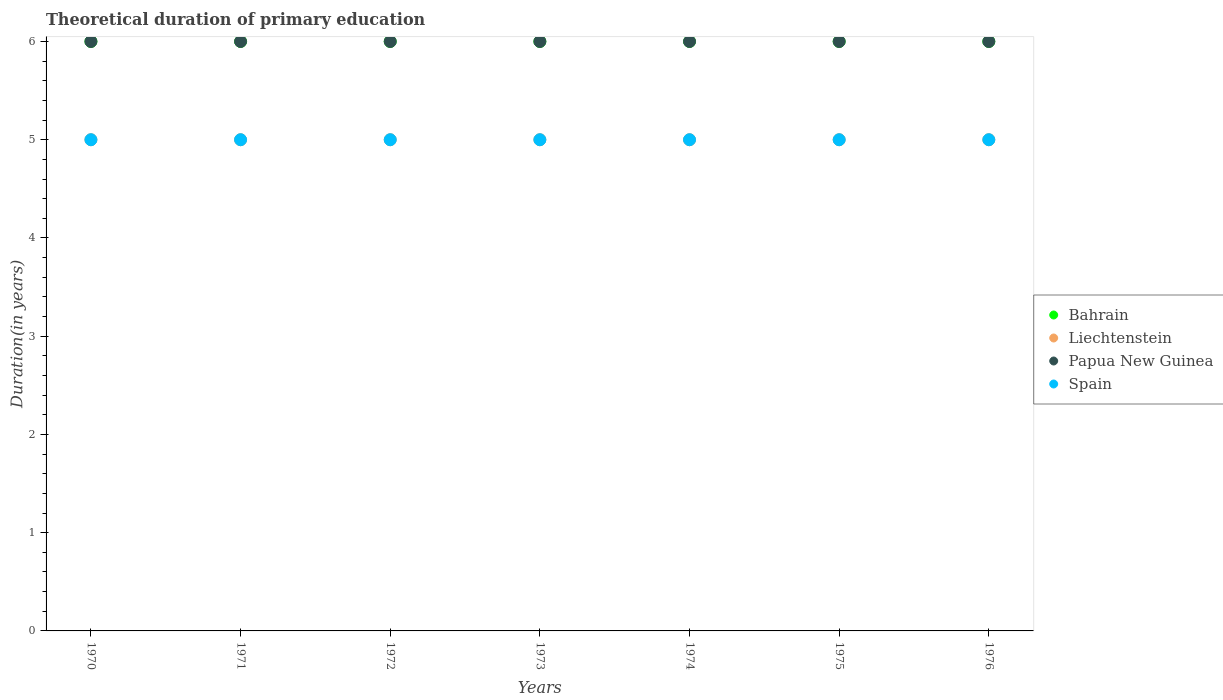How many different coloured dotlines are there?
Keep it short and to the point. 4. What is the total theoretical duration of primary education in Liechtenstein in 1973?
Your answer should be very brief. 5. Across all years, what is the minimum total theoretical duration of primary education in Papua New Guinea?
Provide a short and direct response. 6. In which year was the total theoretical duration of primary education in Bahrain maximum?
Make the answer very short. 1970. What is the total total theoretical duration of primary education in Spain in the graph?
Your answer should be very brief. 35. What is the difference between the total theoretical duration of primary education in Bahrain in 1973 and the total theoretical duration of primary education in Liechtenstein in 1970?
Your answer should be compact. 1. In the year 1971, what is the difference between the total theoretical duration of primary education in Spain and total theoretical duration of primary education in Papua New Guinea?
Offer a very short reply. -1. What is the difference between the highest and the second highest total theoretical duration of primary education in Papua New Guinea?
Give a very brief answer. 0. What is the difference between the highest and the lowest total theoretical duration of primary education in Papua New Guinea?
Your response must be concise. 0. In how many years, is the total theoretical duration of primary education in Papua New Guinea greater than the average total theoretical duration of primary education in Papua New Guinea taken over all years?
Provide a short and direct response. 0. Is the sum of the total theoretical duration of primary education in Spain in 1971 and 1973 greater than the maximum total theoretical duration of primary education in Liechtenstein across all years?
Your answer should be compact. Yes. Is the total theoretical duration of primary education in Bahrain strictly greater than the total theoretical duration of primary education in Papua New Guinea over the years?
Provide a short and direct response. No. What is the difference between two consecutive major ticks on the Y-axis?
Give a very brief answer. 1. Are the values on the major ticks of Y-axis written in scientific E-notation?
Your response must be concise. No. Does the graph contain any zero values?
Your answer should be very brief. No. Where does the legend appear in the graph?
Keep it short and to the point. Center right. What is the title of the graph?
Keep it short and to the point. Theoretical duration of primary education. Does "Fiji" appear as one of the legend labels in the graph?
Offer a very short reply. No. What is the label or title of the Y-axis?
Offer a terse response. Duration(in years). What is the Duration(in years) in Bahrain in 1970?
Provide a succinct answer. 6. What is the Duration(in years) in Papua New Guinea in 1970?
Your response must be concise. 6. What is the Duration(in years) of Bahrain in 1971?
Give a very brief answer. 6. What is the Duration(in years) in Spain in 1971?
Offer a terse response. 5. What is the Duration(in years) in Bahrain in 1973?
Offer a terse response. 6. What is the Duration(in years) in Bahrain in 1974?
Offer a terse response. 6. What is the Duration(in years) of Spain in 1974?
Keep it short and to the point. 5. What is the Duration(in years) of Bahrain in 1975?
Offer a terse response. 6. What is the Duration(in years) in Papua New Guinea in 1975?
Your answer should be compact. 6. What is the Duration(in years) in Spain in 1975?
Give a very brief answer. 5. What is the Duration(in years) in Bahrain in 1976?
Offer a terse response. 6. What is the Duration(in years) of Papua New Guinea in 1976?
Your response must be concise. 6. Across all years, what is the maximum Duration(in years) of Papua New Guinea?
Your answer should be compact. 6. Across all years, what is the minimum Duration(in years) of Papua New Guinea?
Provide a short and direct response. 6. Across all years, what is the minimum Duration(in years) of Spain?
Give a very brief answer. 5. What is the total Duration(in years) of Bahrain in the graph?
Your response must be concise. 42. What is the total Duration(in years) of Liechtenstein in the graph?
Your answer should be compact. 35. What is the total Duration(in years) of Spain in the graph?
Your answer should be very brief. 35. What is the difference between the Duration(in years) of Spain in 1970 and that in 1971?
Keep it short and to the point. 0. What is the difference between the Duration(in years) of Bahrain in 1970 and that in 1972?
Ensure brevity in your answer.  0. What is the difference between the Duration(in years) of Liechtenstein in 1970 and that in 1972?
Your answer should be compact. 0. What is the difference between the Duration(in years) in Papua New Guinea in 1970 and that in 1973?
Your answer should be compact. 0. What is the difference between the Duration(in years) in Bahrain in 1970 and that in 1974?
Your response must be concise. 0. What is the difference between the Duration(in years) in Liechtenstein in 1970 and that in 1974?
Your answer should be very brief. 0. What is the difference between the Duration(in years) in Papua New Guinea in 1970 and that in 1974?
Ensure brevity in your answer.  0. What is the difference between the Duration(in years) of Bahrain in 1970 and that in 1975?
Your answer should be very brief. 0. What is the difference between the Duration(in years) of Papua New Guinea in 1970 and that in 1975?
Give a very brief answer. 0. What is the difference between the Duration(in years) in Spain in 1970 and that in 1975?
Ensure brevity in your answer.  0. What is the difference between the Duration(in years) of Spain in 1970 and that in 1976?
Keep it short and to the point. 0. What is the difference between the Duration(in years) of Spain in 1971 and that in 1972?
Offer a terse response. 0. What is the difference between the Duration(in years) of Bahrain in 1971 and that in 1973?
Provide a short and direct response. 0. What is the difference between the Duration(in years) in Spain in 1971 and that in 1973?
Provide a succinct answer. 0. What is the difference between the Duration(in years) in Papua New Guinea in 1971 and that in 1974?
Give a very brief answer. 0. What is the difference between the Duration(in years) of Bahrain in 1971 and that in 1975?
Make the answer very short. 0. What is the difference between the Duration(in years) in Liechtenstein in 1971 and that in 1975?
Your answer should be compact. 0. What is the difference between the Duration(in years) of Papua New Guinea in 1971 and that in 1975?
Give a very brief answer. 0. What is the difference between the Duration(in years) in Spain in 1971 and that in 1975?
Your response must be concise. 0. What is the difference between the Duration(in years) of Bahrain in 1971 and that in 1976?
Offer a terse response. 0. What is the difference between the Duration(in years) in Liechtenstein in 1971 and that in 1976?
Give a very brief answer. 0. What is the difference between the Duration(in years) of Bahrain in 1972 and that in 1973?
Offer a very short reply. 0. What is the difference between the Duration(in years) of Bahrain in 1972 and that in 1974?
Provide a succinct answer. 0. What is the difference between the Duration(in years) of Bahrain in 1972 and that in 1976?
Your response must be concise. 0. What is the difference between the Duration(in years) in Liechtenstein in 1972 and that in 1976?
Your answer should be very brief. 0. What is the difference between the Duration(in years) in Papua New Guinea in 1972 and that in 1976?
Offer a terse response. 0. What is the difference between the Duration(in years) in Spain in 1972 and that in 1976?
Give a very brief answer. 0. What is the difference between the Duration(in years) of Spain in 1973 and that in 1974?
Provide a succinct answer. 0. What is the difference between the Duration(in years) in Spain in 1973 and that in 1975?
Make the answer very short. 0. What is the difference between the Duration(in years) of Bahrain in 1974 and that in 1975?
Ensure brevity in your answer.  0. What is the difference between the Duration(in years) of Liechtenstein in 1974 and that in 1975?
Your response must be concise. 0. What is the difference between the Duration(in years) of Spain in 1974 and that in 1975?
Offer a very short reply. 0. What is the difference between the Duration(in years) of Bahrain in 1974 and that in 1976?
Offer a terse response. 0. What is the difference between the Duration(in years) of Bahrain in 1975 and that in 1976?
Give a very brief answer. 0. What is the difference between the Duration(in years) in Papua New Guinea in 1975 and that in 1976?
Offer a terse response. 0. What is the difference between the Duration(in years) of Bahrain in 1970 and the Duration(in years) of Liechtenstein in 1971?
Provide a succinct answer. 1. What is the difference between the Duration(in years) in Bahrain in 1970 and the Duration(in years) in Papua New Guinea in 1971?
Your response must be concise. 0. What is the difference between the Duration(in years) in Bahrain in 1970 and the Duration(in years) in Spain in 1971?
Make the answer very short. 1. What is the difference between the Duration(in years) in Liechtenstein in 1970 and the Duration(in years) in Papua New Guinea in 1971?
Your response must be concise. -1. What is the difference between the Duration(in years) of Bahrain in 1970 and the Duration(in years) of Papua New Guinea in 1972?
Keep it short and to the point. 0. What is the difference between the Duration(in years) of Liechtenstein in 1970 and the Duration(in years) of Spain in 1972?
Make the answer very short. 0. What is the difference between the Duration(in years) in Papua New Guinea in 1970 and the Duration(in years) in Spain in 1972?
Ensure brevity in your answer.  1. What is the difference between the Duration(in years) of Bahrain in 1970 and the Duration(in years) of Papua New Guinea in 1973?
Offer a very short reply. 0. What is the difference between the Duration(in years) in Bahrain in 1970 and the Duration(in years) in Spain in 1973?
Your answer should be very brief. 1. What is the difference between the Duration(in years) in Liechtenstein in 1970 and the Duration(in years) in Papua New Guinea in 1973?
Offer a very short reply. -1. What is the difference between the Duration(in years) of Liechtenstein in 1970 and the Duration(in years) of Spain in 1973?
Your response must be concise. 0. What is the difference between the Duration(in years) of Bahrain in 1970 and the Duration(in years) of Papua New Guinea in 1974?
Ensure brevity in your answer.  0. What is the difference between the Duration(in years) of Liechtenstein in 1970 and the Duration(in years) of Papua New Guinea in 1974?
Offer a very short reply. -1. What is the difference between the Duration(in years) in Liechtenstein in 1970 and the Duration(in years) in Spain in 1974?
Your response must be concise. 0. What is the difference between the Duration(in years) in Papua New Guinea in 1970 and the Duration(in years) in Spain in 1974?
Provide a succinct answer. 1. What is the difference between the Duration(in years) of Bahrain in 1970 and the Duration(in years) of Liechtenstein in 1975?
Keep it short and to the point. 1. What is the difference between the Duration(in years) in Bahrain in 1970 and the Duration(in years) in Papua New Guinea in 1975?
Offer a very short reply. 0. What is the difference between the Duration(in years) of Bahrain in 1970 and the Duration(in years) of Papua New Guinea in 1976?
Provide a succinct answer. 0. What is the difference between the Duration(in years) of Liechtenstein in 1970 and the Duration(in years) of Spain in 1976?
Make the answer very short. 0. What is the difference between the Duration(in years) in Bahrain in 1971 and the Duration(in years) in Spain in 1972?
Offer a very short reply. 1. What is the difference between the Duration(in years) in Liechtenstein in 1971 and the Duration(in years) in Papua New Guinea in 1972?
Make the answer very short. -1. What is the difference between the Duration(in years) in Liechtenstein in 1971 and the Duration(in years) in Spain in 1972?
Provide a short and direct response. 0. What is the difference between the Duration(in years) in Papua New Guinea in 1971 and the Duration(in years) in Spain in 1972?
Your response must be concise. 1. What is the difference between the Duration(in years) in Bahrain in 1971 and the Duration(in years) in Liechtenstein in 1973?
Give a very brief answer. 1. What is the difference between the Duration(in years) in Liechtenstein in 1971 and the Duration(in years) in Spain in 1973?
Provide a short and direct response. 0. What is the difference between the Duration(in years) in Papua New Guinea in 1971 and the Duration(in years) in Spain in 1973?
Provide a short and direct response. 1. What is the difference between the Duration(in years) in Bahrain in 1971 and the Duration(in years) in Liechtenstein in 1974?
Keep it short and to the point. 1. What is the difference between the Duration(in years) of Bahrain in 1971 and the Duration(in years) of Spain in 1974?
Give a very brief answer. 1. What is the difference between the Duration(in years) in Liechtenstein in 1971 and the Duration(in years) in Spain in 1974?
Keep it short and to the point. 0. What is the difference between the Duration(in years) of Papua New Guinea in 1971 and the Duration(in years) of Spain in 1974?
Give a very brief answer. 1. What is the difference between the Duration(in years) in Bahrain in 1971 and the Duration(in years) in Papua New Guinea in 1975?
Provide a short and direct response. 0. What is the difference between the Duration(in years) in Liechtenstein in 1971 and the Duration(in years) in Papua New Guinea in 1975?
Provide a short and direct response. -1. What is the difference between the Duration(in years) of Liechtenstein in 1971 and the Duration(in years) of Spain in 1975?
Your response must be concise. 0. What is the difference between the Duration(in years) of Papua New Guinea in 1971 and the Duration(in years) of Spain in 1975?
Give a very brief answer. 1. What is the difference between the Duration(in years) of Bahrain in 1971 and the Duration(in years) of Liechtenstein in 1976?
Ensure brevity in your answer.  1. What is the difference between the Duration(in years) of Bahrain in 1971 and the Duration(in years) of Spain in 1976?
Make the answer very short. 1. What is the difference between the Duration(in years) in Liechtenstein in 1971 and the Duration(in years) in Spain in 1976?
Make the answer very short. 0. What is the difference between the Duration(in years) in Bahrain in 1972 and the Duration(in years) in Liechtenstein in 1973?
Provide a succinct answer. 1. What is the difference between the Duration(in years) of Bahrain in 1972 and the Duration(in years) of Papua New Guinea in 1973?
Provide a short and direct response. 0. What is the difference between the Duration(in years) of Bahrain in 1972 and the Duration(in years) of Spain in 1973?
Offer a terse response. 1. What is the difference between the Duration(in years) of Liechtenstein in 1972 and the Duration(in years) of Papua New Guinea in 1973?
Offer a very short reply. -1. What is the difference between the Duration(in years) in Liechtenstein in 1972 and the Duration(in years) in Spain in 1973?
Your response must be concise. 0. What is the difference between the Duration(in years) in Bahrain in 1972 and the Duration(in years) in Liechtenstein in 1974?
Offer a terse response. 1. What is the difference between the Duration(in years) in Liechtenstein in 1972 and the Duration(in years) in Papua New Guinea in 1974?
Offer a very short reply. -1. What is the difference between the Duration(in years) in Liechtenstein in 1972 and the Duration(in years) in Spain in 1974?
Ensure brevity in your answer.  0. What is the difference between the Duration(in years) of Bahrain in 1972 and the Duration(in years) of Papua New Guinea in 1975?
Offer a very short reply. 0. What is the difference between the Duration(in years) of Bahrain in 1972 and the Duration(in years) of Spain in 1975?
Ensure brevity in your answer.  1. What is the difference between the Duration(in years) of Papua New Guinea in 1972 and the Duration(in years) of Spain in 1975?
Give a very brief answer. 1. What is the difference between the Duration(in years) of Liechtenstein in 1972 and the Duration(in years) of Spain in 1976?
Provide a succinct answer. 0. What is the difference between the Duration(in years) in Bahrain in 1973 and the Duration(in years) in Liechtenstein in 1974?
Give a very brief answer. 1. What is the difference between the Duration(in years) of Bahrain in 1973 and the Duration(in years) of Papua New Guinea in 1974?
Offer a very short reply. 0. What is the difference between the Duration(in years) of Liechtenstein in 1973 and the Duration(in years) of Spain in 1974?
Make the answer very short. 0. What is the difference between the Duration(in years) of Papua New Guinea in 1973 and the Duration(in years) of Spain in 1974?
Offer a very short reply. 1. What is the difference between the Duration(in years) of Bahrain in 1973 and the Duration(in years) of Liechtenstein in 1975?
Your answer should be compact. 1. What is the difference between the Duration(in years) in Liechtenstein in 1973 and the Duration(in years) in Papua New Guinea in 1975?
Keep it short and to the point. -1. What is the difference between the Duration(in years) in Liechtenstein in 1973 and the Duration(in years) in Spain in 1975?
Give a very brief answer. 0. What is the difference between the Duration(in years) in Papua New Guinea in 1973 and the Duration(in years) in Spain in 1975?
Provide a short and direct response. 1. What is the difference between the Duration(in years) of Bahrain in 1973 and the Duration(in years) of Spain in 1976?
Give a very brief answer. 1. What is the difference between the Duration(in years) in Liechtenstein in 1973 and the Duration(in years) in Papua New Guinea in 1976?
Your response must be concise. -1. What is the difference between the Duration(in years) in Bahrain in 1974 and the Duration(in years) in Liechtenstein in 1975?
Provide a succinct answer. 1. What is the difference between the Duration(in years) of Bahrain in 1974 and the Duration(in years) of Papua New Guinea in 1975?
Offer a terse response. 0. What is the difference between the Duration(in years) in Liechtenstein in 1974 and the Duration(in years) in Papua New Guinea in 1976?
Give a very brief answer. -1. What is the difference between the Duration(in years) in Liechtenstein in 1974 and the Duration(in years) in Spain in 1976?
Your answer should be compact. 0. What is the difference between the Duration(in years) of Bahrain in 1975 and the Duration(in years) of Liechtenstein in 1976?
Your answer should be very brief. 1. What is the difference between the Duration(in years) of Bahrain in 1975 and the Duration(in years) of Spain in 1976?
Your answer should be very brief. 1. What is the difference between the Duration(in years) in Liechtenstein in 1975 and the Duration(in years) in Papua New Guinea in 1976?
Your response must be concise. -1. What is the difference between the Duration(in years) of Papua New Guinea in 1975 and the Duration(in years) of Spain in 1976?
Keep it short and to the point. 1. What is the average Duration(in years) of Liechtenstein per year?
Give a very brief answer. 5. In the year 1970, what is the difference between the Duration(in years) of Bahrain and Duration(in years) of Liechtenstein?
Ensure brevity in your answer.  1. In the year 1970, what is the difference between the Duration(in years) of Bahrain and Duration(in years) of Papua New Guinea?
Your response must be concise. 0. In the year 1970, what is the difference between the Duration(in years) of Liechtenstein and Duration(in years) of Papua New Guinea?
Keep it short and to the point. -1. In the year 1971, what is the difference between the Duration(in years) in Bahrain and Duration(in years) in Liechtenstein?
Your answer should be compact. 1. In the year 1971, what is the difference between the Duration(in years) of Liechtenstein and Duration(in years) of Spain?
Make the answer very short. 0. In the year 1972, what is the difference between the Duration(in years) of Bahrain and Duration(in years) of Spain?
Provide a succinct answer. 1. In the year 1972, what is the difference between the Duration(in years) of Liechtenstein and Duration(in years) of Papua New Guinea?
Make the answer very short. -1. In the year 1972, what is the difference between the Duration(in years) of Liechtenstein and Duration(in years) of Spain?
Make the answer very short. 0. In the year 1972, what is the difference between the Duration(in years) of Papua New Guinea and Duration(in years) of Spain?
Your answer should be compact. 1. In the year 1973, what is the difference between the Duration(in years) of Bahrain and Duration(in years) of Papua New Guinea?
Ensure brevity in your answer.  0. In the year 1973, what is the difference between the Duration(in years) in Bahrain and Duration(in years) in Spain?
Your answer should be very brief. 1. In the year 1973, what is the difference between the Duration(in years) in Liechtenstein and Duration(in years) in Papua New Guinea?
Make the answer very short. -1. In the year 1973, what is the difference between the Duration(in years) of Papua New Guinea and Duration(in years) of Spain?
Give a very brief answer. 1. In the year 1974, what is the difference between the Duration(in years) of Bahrain and Duration(in years) of Papua New Guinea?
Give a very brief answer. 0. In the year 1974, what is the difference between the Duration(in years) in Papua New Guinea and Duration(in years) in Spain?
Your answer should be very brief. 1. In the year 1975, what is the difference between the Duration(in years) of Bahrain and Duration(in years) of Liechtenstein?
Provide a succinct answer. 1. In the year 1975, what is the difference between the Duration(in years) of Bahrain and Duration(in years) of Spain?
Make the answer very short. 1. In the year 1975, what is the difference between the Duration(in years) in Liechtenstein and Duration(in years) in Papua New Guinea?
Provide a succinct answer. -1. In the year 1976, what is the difference between the Duration(in years) of Bahrain and Duration(in years) of Liechtenstein?
Ensure brevity in your answer.  1. In the year 1976, what is the difference between the Duration(in years) of Liechtenstein and Duration(in years) of Papua New Guinea?
Give a very brief answer. -1. In the year 1976, what is the difference between the Duration(in years) of Liechtenstein and Duration(in years) of Spain?
Make the answer very short. 0. In the year 1976, what is the difference between the Duration(in years) in Papua New Guinea and Duration(in years) in Spain?
Keep it short and to the point. 1. What is the ratio of the Duration(in years) of Liechtenstein in 1970 to that in 1971?
Provide a short and direct response. 1. What is the ratio of the Duration(in years) in Papua New Guinea in 1970 to that in 1971?
Provide a short and direct response. 1. What is the ratio of the Duration(in years) of Spain in 1970 to that in 1971?
Make the answer very short. 1. What is the ratio of the Duration(in years) of Liechtenstein in 1970 to that in 1972?
Give a very brief answer. 1. What is the ratio of the Duration(in years) in Papua New Guinea in 1970 to that in 1972?
Offer a very short reply. 1. What is the ratio of the Duration(in years) of Spain in 1970 to that in 1972?
Provide a short and direct response. 1. What is the ratio of the Duration(in years) of Liechtenstein in 1970 to that in 1973?
Ensure brevity in your answer.  1. What is the ratio of the Duration(in years) in Spain in 1970 to that in 1973?
Offer a very short reply. 1. What is the ratio of the Duration(in years) of Bahrain in 1970 to that in 1975?
Your answer should be very brief. 1. What is the ratio of the Duration(in years) in Papua New Guinea in 1970 to that in 1975?
Provide a short and direct response. 1. What is the ratio of the Duration(in years) of Papua New Guinea in 1970 to that in 1976?
Provide a succinct answer. 1. What is the ratio of the Duration(in years) in Liechtenstein in 1971 to that in 1972?
Keep it short and to the point. 1. What is the ratio of the Duration(in years) in Papua New Guinea in 1971 to that in 1973?
Your answer should be very brief. 1. What is the ratio of the Duration(in years) of Liechtenstein in 1971 to that in 1974?
Give a very brief answer. 1. What is the ratio of the Duration(in years) of Spain in 1971 to that in 1975?
Provide a succinct answer. 1. What is the ratio of the Duration(in years) of Bahrain in 1971 to that in 1976?
Offer a terse response. 1. What is the ratio of the Duration(in years) in Papua New Guinea in 1971 to that in 1976?
Provide a short and direct response. 1. What is the ratio of the Duration(in years) in Bahrain in 1972 to that in 1973?
Ensure brevity in your answer.  1. What is the ratio of the Duration(in years) of Liechtenstein in 1972 to that in 1973?
Provide a short and direct response. 1. What is the ratio of the Duration(in years) in Bahrain in 1972 to that in 1974?
Ensure brevity in your answer.  1. What is the ratio of the Duration(in years) of Liechtenstein in 1972 to that in 1974?
Ensure brevity in your answer.  1. What is the ratio of the Duration(in years) in Spain in 1972 to that in 1974?
Your response must be concise. 1. What is the ratio of the Duration(in years) in Spain in 1972 to that in 1975?
Your answer should be compact. 1. What is the ratio of the Duration(in years) of Liechtenstein in 1972 to that in 1976?
Make the answer very short. 1. What is the ratio of the Duration(in years) in Bahrain in 1973 to that in 1974?
Offer a terse response. 1. What is the ratio of the Duration(in years) in Papua New Guinea in 1973 to that in 1974?
Offer a terse response. 1. What is the ratio of the Duration(in years) in Liechtenstein in 1973 to that in 1975?
Offer a terse response. 1. What is the ratio of the Duration(in years) of Spain in 1973 to that in 1975?
Offer a terse response. 1. What is the ratio of the Duration(in years) in Bahrain in 1973 to that in 1976?
Provide a succinct answer. 1. What is the ratio of the Duration(in years) of Liechtenstein in 1973 to that in 1976?
Offer a terse response. 1. What is the ratio of the Duration(in years) of Papua New Guinea in 1973 to that in 1976?
Provide a succinct answer. 1. What is the ratio of the Duration(in years) of Bahrain in 1974 to that in 1975?
Your answer should be compact. 1. What is the ratio of the Duration(in years) in Liechtenstein in 1974 to that in 1975?
Your response must be concise. 1. What is the ratio of the Duration(in years) of Papua New Guinea in 1974 to that in 1975?
Your response must be concise. 1. What is the ratio of the Duration(in years) in Spain in 1974 to that in 1976?
Offer a terse response. 1. What is the ratio of the Duration(in years) in Bahrain in 1975 to that in 1976?
Ensure brevity in your answer.  1. What is the ratio of the Duration(in years) in Papua New Guinea in 1975 to that in 1976?
Offer a terse response. 1. What is the ratio of the Duration(in years) in Spain in 1975 to that in 1976?
Make the answer very short. 1. What is the difference between the highest and the second highest Duration(in years) of Bahrain?
Your answer should be very brief. 0. What is the difference between the highest and the second highest Duration(in years) in Liechtenstein?
Provide a succinct answer. 0. What is the difference between the highest and the lowest Duration(in years) in Bahrain?
Offer a terse response. 0. What is the difference between the highest and the lowest Duration(in years) of Liechtenstein?
Give a very brief answer. 0. What is the difference between the highest and the lowest Duration(in years) of Papua New Guinea?
Keep it short and to the point. 0. What is the difference between the highest and the lowest Duration(in years) of Spain?
Offer a very short reply. 0. 